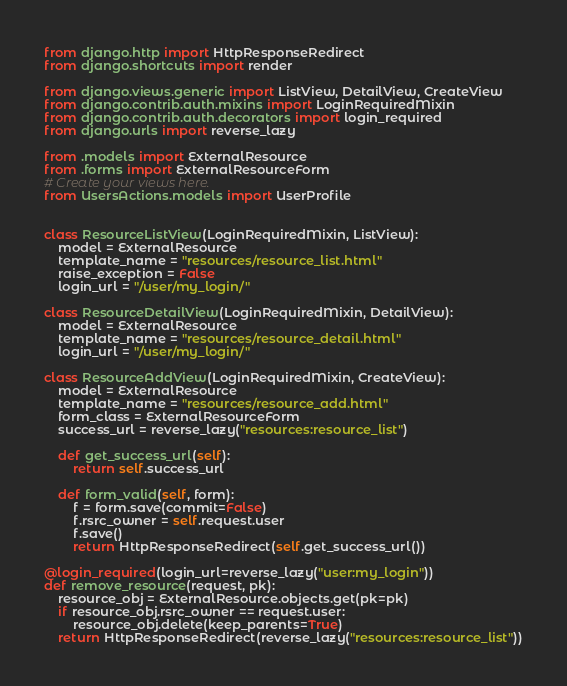<code> <loc_0><loc_0><loc_500><loc_500><_Python_>from django.http import HttpResponseRedirect
from django.shortcuts import render

from django.views.generic import ListView, DetailView, CreateView
from django.contrib.auth.mixins import LoginRequiredMixin
from django.contrib.auth.decorators import login_required
from django.urls import reverse_lazy

from .models import ExternalResource
from .forms import ExternalResourceForm
# Create your views here.
from UsersActions.models import UserProfile


class ResourceListView(LoginRequiredMixin, ListView):
    model = ExternalResource
    template_name = "resources/resource_list.html"
    raise_exception = False
    login_url = "/user/my_login/"

class ResourceDetailView(LoginRequiredMixin, DetailView):
    model = ExternalResource
    template_name = "resources/resource_detail.html"
    login_url = "/user/my_login/"

class ResourceAddView(LoginRequiredMixin, CreateView):
    model = ExternalResource
    template_name = "resources/resource_add.html"
    form_class = ExternalResourceForm
    success_url = reverse_lazy("resources:resource_list")

    def get_success_url(self):
        return self.success_url

    def form_valid(self, form):
        f = form.save(commit=False)
        f.rsrc_owner = self.request.user
        f.save()
        return HttpResponseRedirect(self.get_success_url())

@login_required(login_url=reverse_lazy("user:my_login"))
def remove_resource(request, pk):
    resource_obj = ExternalResource.objects.get(pk=pk)
    if resource_obj.rsrc_owner == request.user:
        resource_obj.delete(keep_parents=True)
    return HttpResponseRedirect(reverse_lazy("resources:resource_list"))</code> 